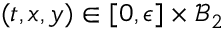Convert formula to latex. <formula><loc_0><loc_0><loc_500><loc_500>( t , x , y ) \in [ 0 , \epsilon ] \times \mathcal { B } _ { 2 }</formula> 